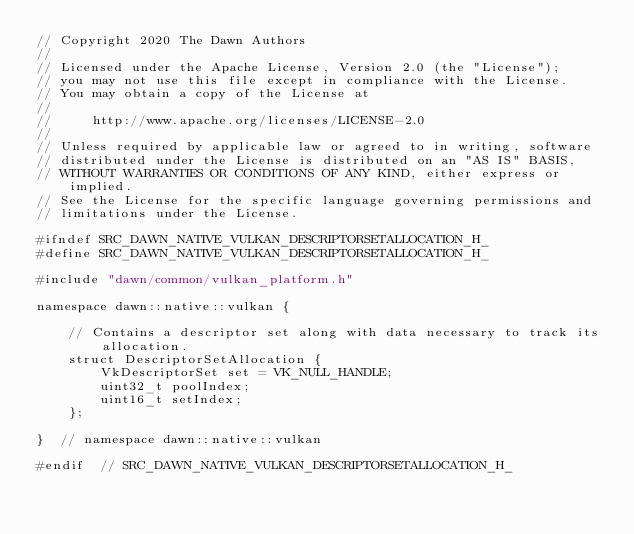<code> <loc_0><loc_0><loc_500><loc_500><_C_>// Copyright 2020 The Dawn Authors
//
// Licensed under the Apache License, Version 2.0 (the "License");
// you may not use this file except in compliance with the License.
// You may obtain a copy of the License at
//
//     http://www.apache.org/licenses/LICENSE-2.0
//
// Unless required by applicable law or agreed to in writing, software
// distributed under the License is distributed on an "AS IS" BASIS,
// WITHOUT WARRANTIES OR CONDITIONS OF ANY KIND, either express or implied.
// See the License for the specific language governing permissions and
// limitations under the License.

#ifndef SRC_DAWN_NATIVE_VULKAN_DESCRIPTORSETALLOCATION_H_
#define SRC_DAWN_NATIVE_VULKAN_DESCRIPTORSETALLOCATION_H_

#include "dawn/common/vulkan_platform.h"

namespace dawn::native::vulkan {

    // Contains a descriptor set along with data necessary to track its allocation.
    struct DescriptorSetAllocation {
        VkDescriptorSet set = VK_NULL_HANDLE;
        uint32_t poolIndex;
        uint16_t setIndex;
    };

}  // namespace dawn::native::vulkan

#endif  // SRC_DAWN_NATIVE_VULKAN_DESCRIPTORSETALLOCATION_H_
</code> 